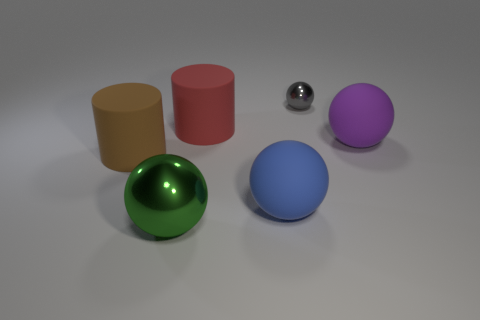What shape is the green shiny thing that is the same size as the purple sphere?
Your answer should be compact. Sphere. Is there a metallic ball that has the same color as the small metallic object?
Your answer should be compact. No. The green metallic thing is what size?
Give a very brief answer. Large. Does the blue object have the same material as the large red object?
Give a very brief answer. Yes. How many big blue objects are left of the thing behind the cylinder behind the brown cylinder?
Provide a succinct answer. 1. The big brown rubber thing that is in front of the red matte cylinder has what shape?
Offer a terse response. Cylinder. What number of other objects are the same material as the purple ball?
Give a very brief answer. 3. Is the color of the big shiny ball the same as the tiny thing?
Offer a terse response. No. Are there fewer metallic objects in front of the red thing than blue things behind the brown matte cylinder?
Your response must be concise. No. What color is the tiny object that is the same shape as the large purple thing?
Keep it short and to the point. Gray. 